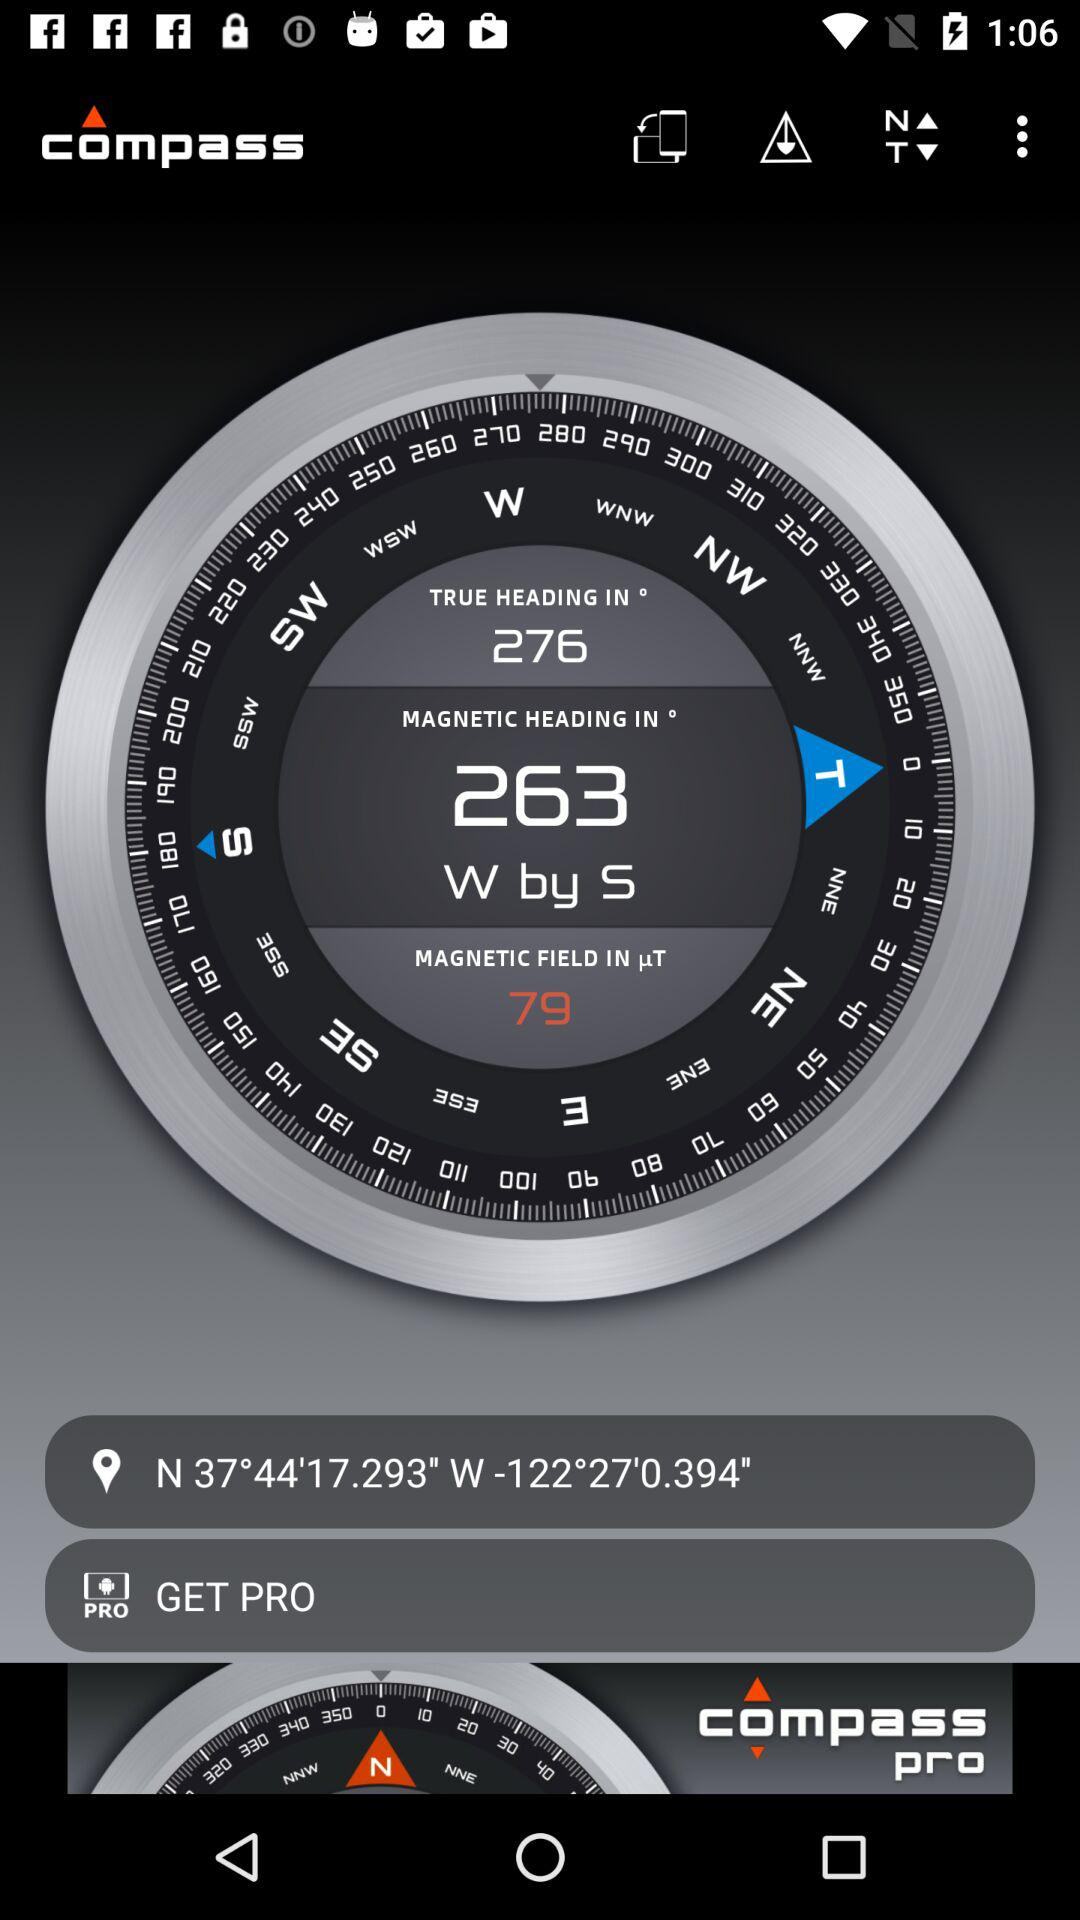What is the latitude? The latitude is N 37°44'17.293′′. 